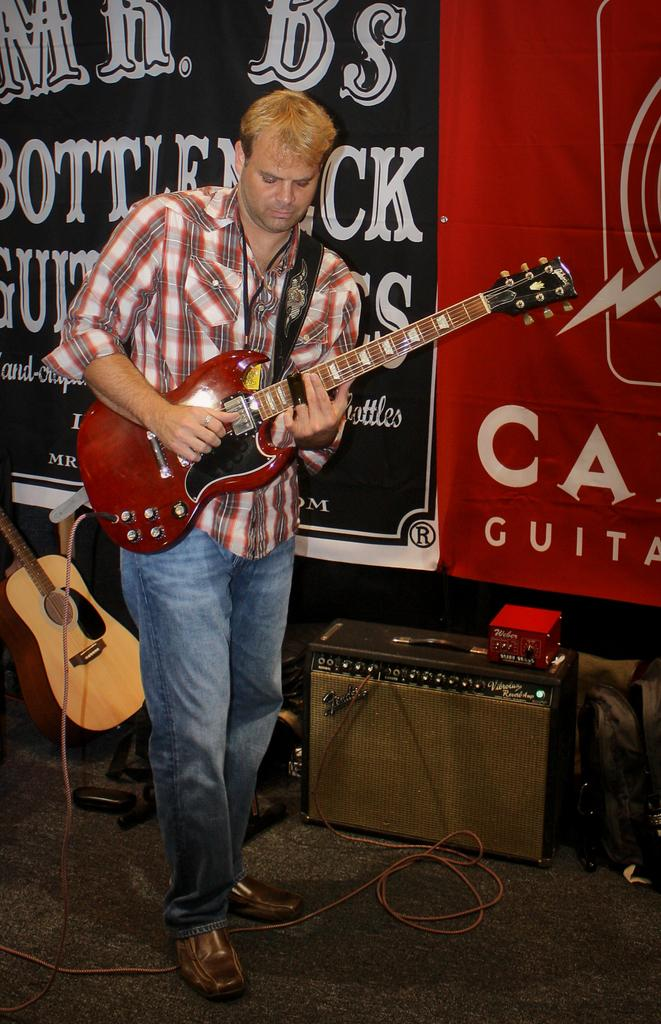What is the man in the image doing? The man is playing a guitar in the image. What object can be seen near the man? There appears to be a speaker in the image. What color is the object in the image? There is a red object in the image. What other musical instrument is present in the image? There is another guitar in the image. What type of signage is visible in the image? There are banners with letters in the image. How many rabbits can be seen playing with the ball in the image? There are no rabbits or balls present in the image. What color are the eyes of the rabbit in the image? There is no rabbit in the image, so there are no eyes to describe. 